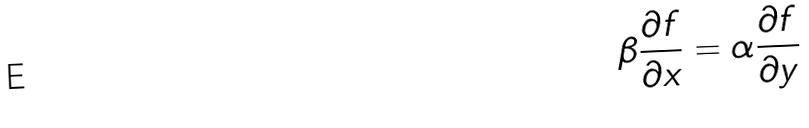<formula> <loc_0><loc_0><loc_500><loc_500>\beta \frac { \partial f } { \partial x } = \alpha \frac { \partial f } { \partial y }</formula> 